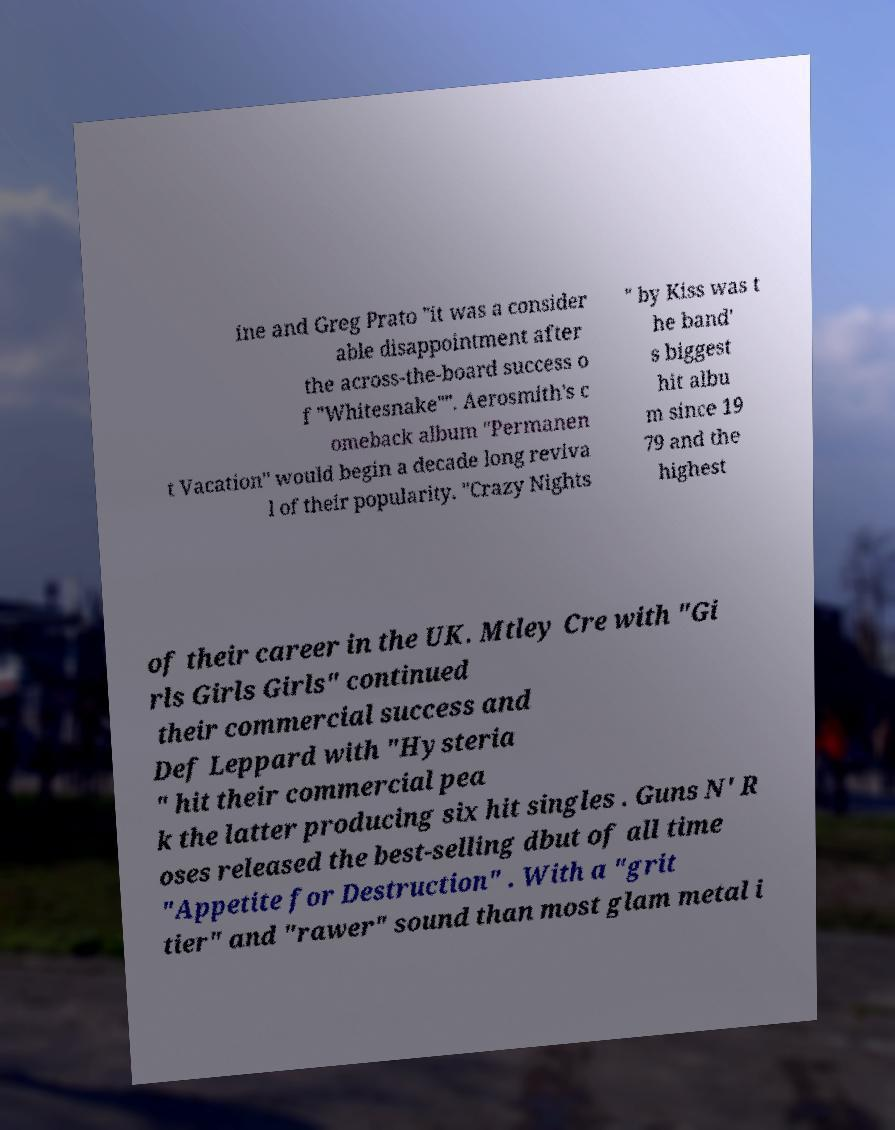What messages or text are displayed in this image? I need them in a readable, typed format. ine and Greg Prato "it was a consider able disappointment after the across-the-board success o f "Whitesnake"". Aerosmith's c omeback album "Permanen t Vacation" would begin a decade long reviva l of their popularity. "Crazy Nights " by Kiss was t he band' s biggest hit albu m since 19 79 and the highest of their career in the UK. Mtley Cre with "Gi rls Girls Girls" continued their commercial success and Def Leppard with "Hysteria " hit their commercial pea k the latter producing six hit singles . Guns N' R oses released the best-selling dbut of all time "Appetite for Destruction" . With a "grit tier" and "rawer" sound than most glam metal i 